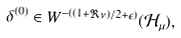<formula> <loc_0><loc_0><loc_500><loc_500>\delta ^ { ( 0 ) } \in W ^ { - ( ( 1 + \Re \nu ) / 2 + \epsilon ) } ( \mathcal { H } _ { \mu } ) ,</formula> 